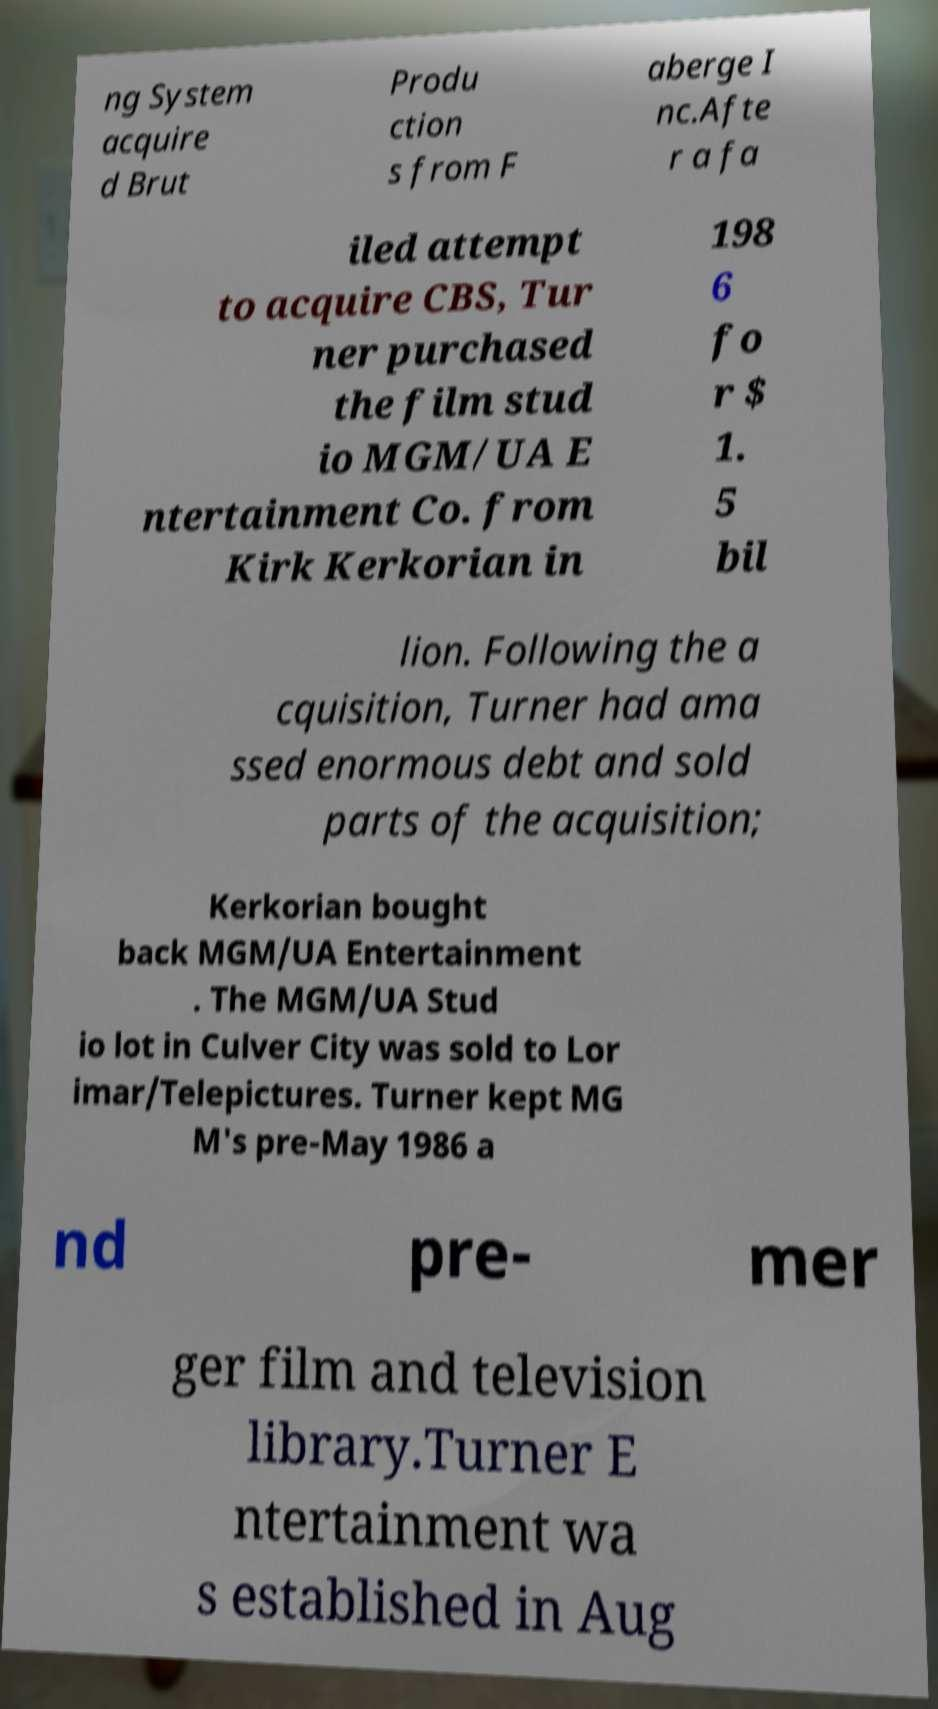What messages or text are displayed in this image? I need them in a readable, typed format. ng System acquire d Brut Produ ction s from F aberge I nc.Afte r a fa iled attempt to acquire CBS, Tur ner purchased the film stud io MGM/UA E ntertainment Co. from Kirk Kerkorian in 198 6 fo r $ 1. 5 bil lion. Following the a cquisition, Turner had ama ssed enormous debt and sold parts of the acquisition; Kerkorian bought back MGM/UA Entertainment . The MGM/UA Stud io lot in Culver City was sold to Lor imar/Telepictures. Turner kept MG M's pre-May 1986 a nd pre- mer ger film and television library.Turner E ntertainment wa s established in Aug 